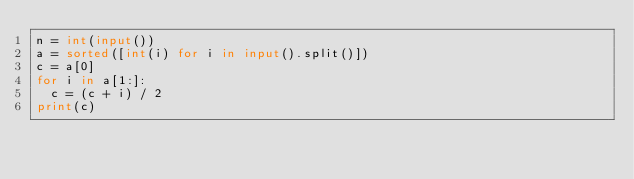<code> <loc_0><loc_0><loc_500><loc_500><_Python_>n = int(input())
a = sorted([int(i) for i in input().split()])
c = a[0]
for i in a[1:]:
  c = (c + i) / 2
print(c)
</code> 